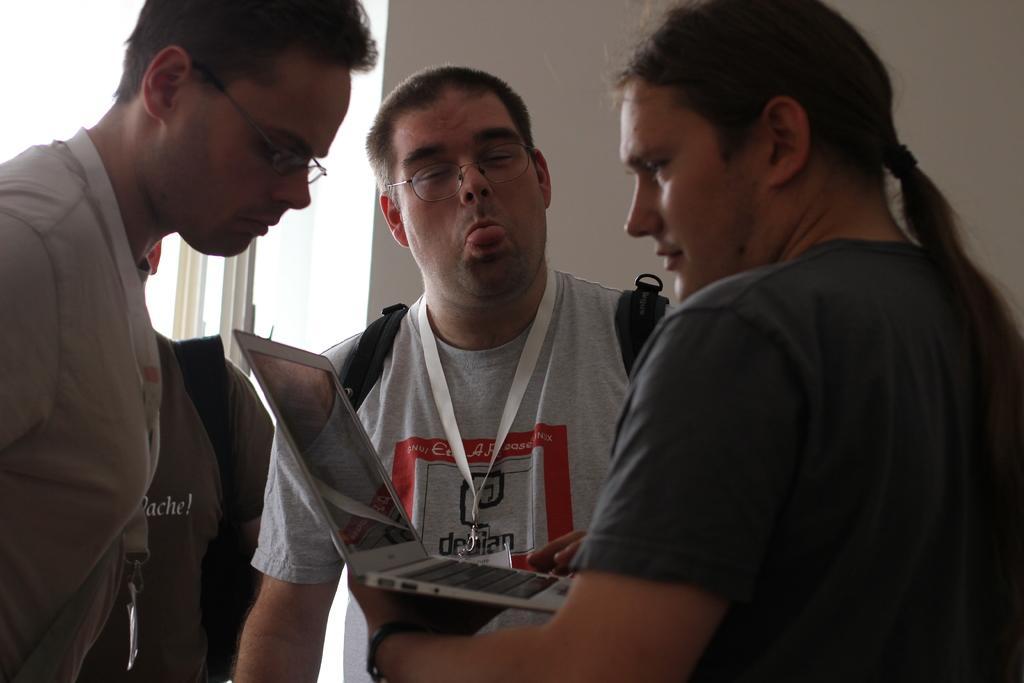Could you give a brief overview of what you see in this image? In the image we can see there are people wearing clothes and two of them are wearing spectacles and identity card. This is a laptop, hairband, bag and a wall. 